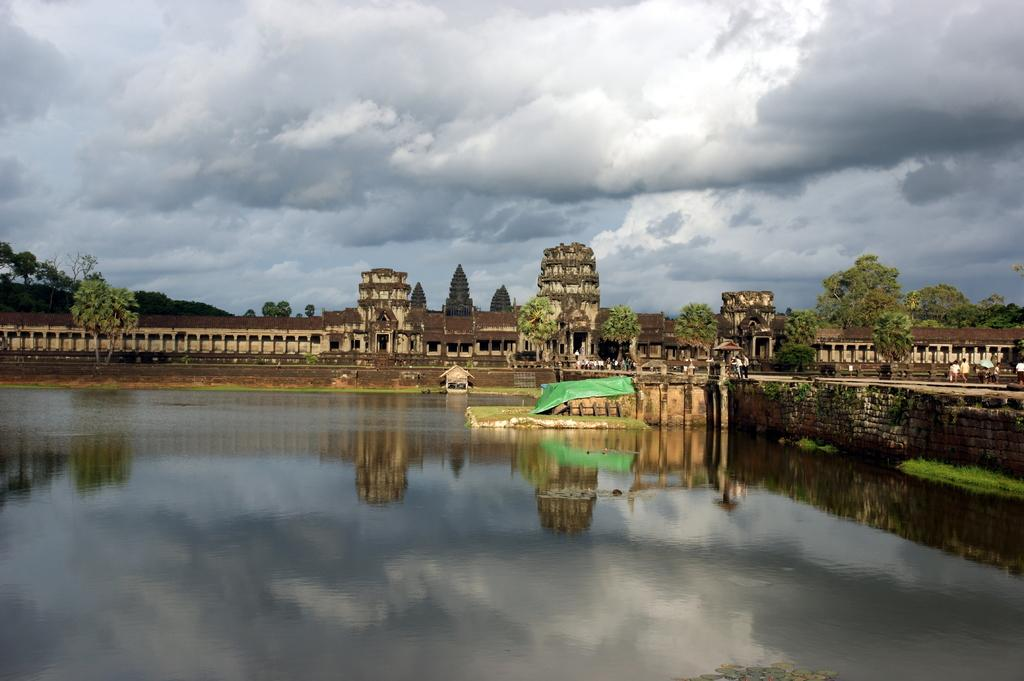What is the primary element present in the image? There is water in the image. Can you describe the people in the image? There is a group of people in the image. What structures are visible in the image? There are buildings in the image. What type of vegetation can be seen in the image? There are trees in the image. What is visible in the background of the image? The sky is visible in the background of the image. What type of bone is being used as a caption for the image? There is no bone or caption present in the image. Can you tell me how many horses are in the image? There are no horses present in the image. 